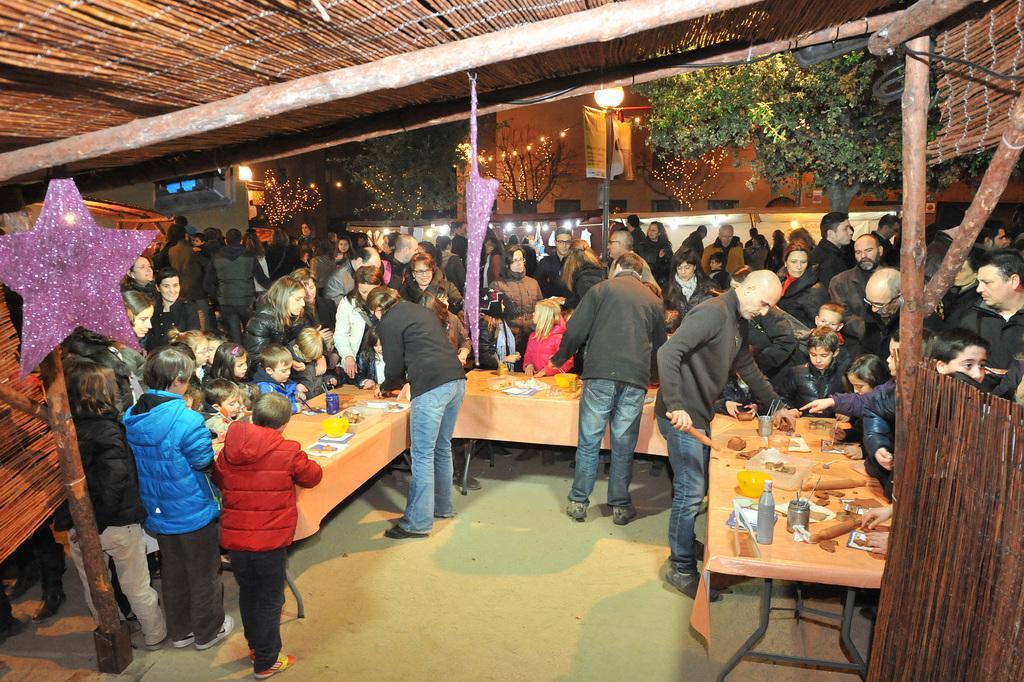Could you give a brief overview of what you see in this image? In the image it looks like some event is being conducted among the kids, the kids were sitting in front of the tables and on the tables there are different items placed, around them there is huge crowd and there is a shelter above the people. In the background there is a building and in front of the building there is a tree. 